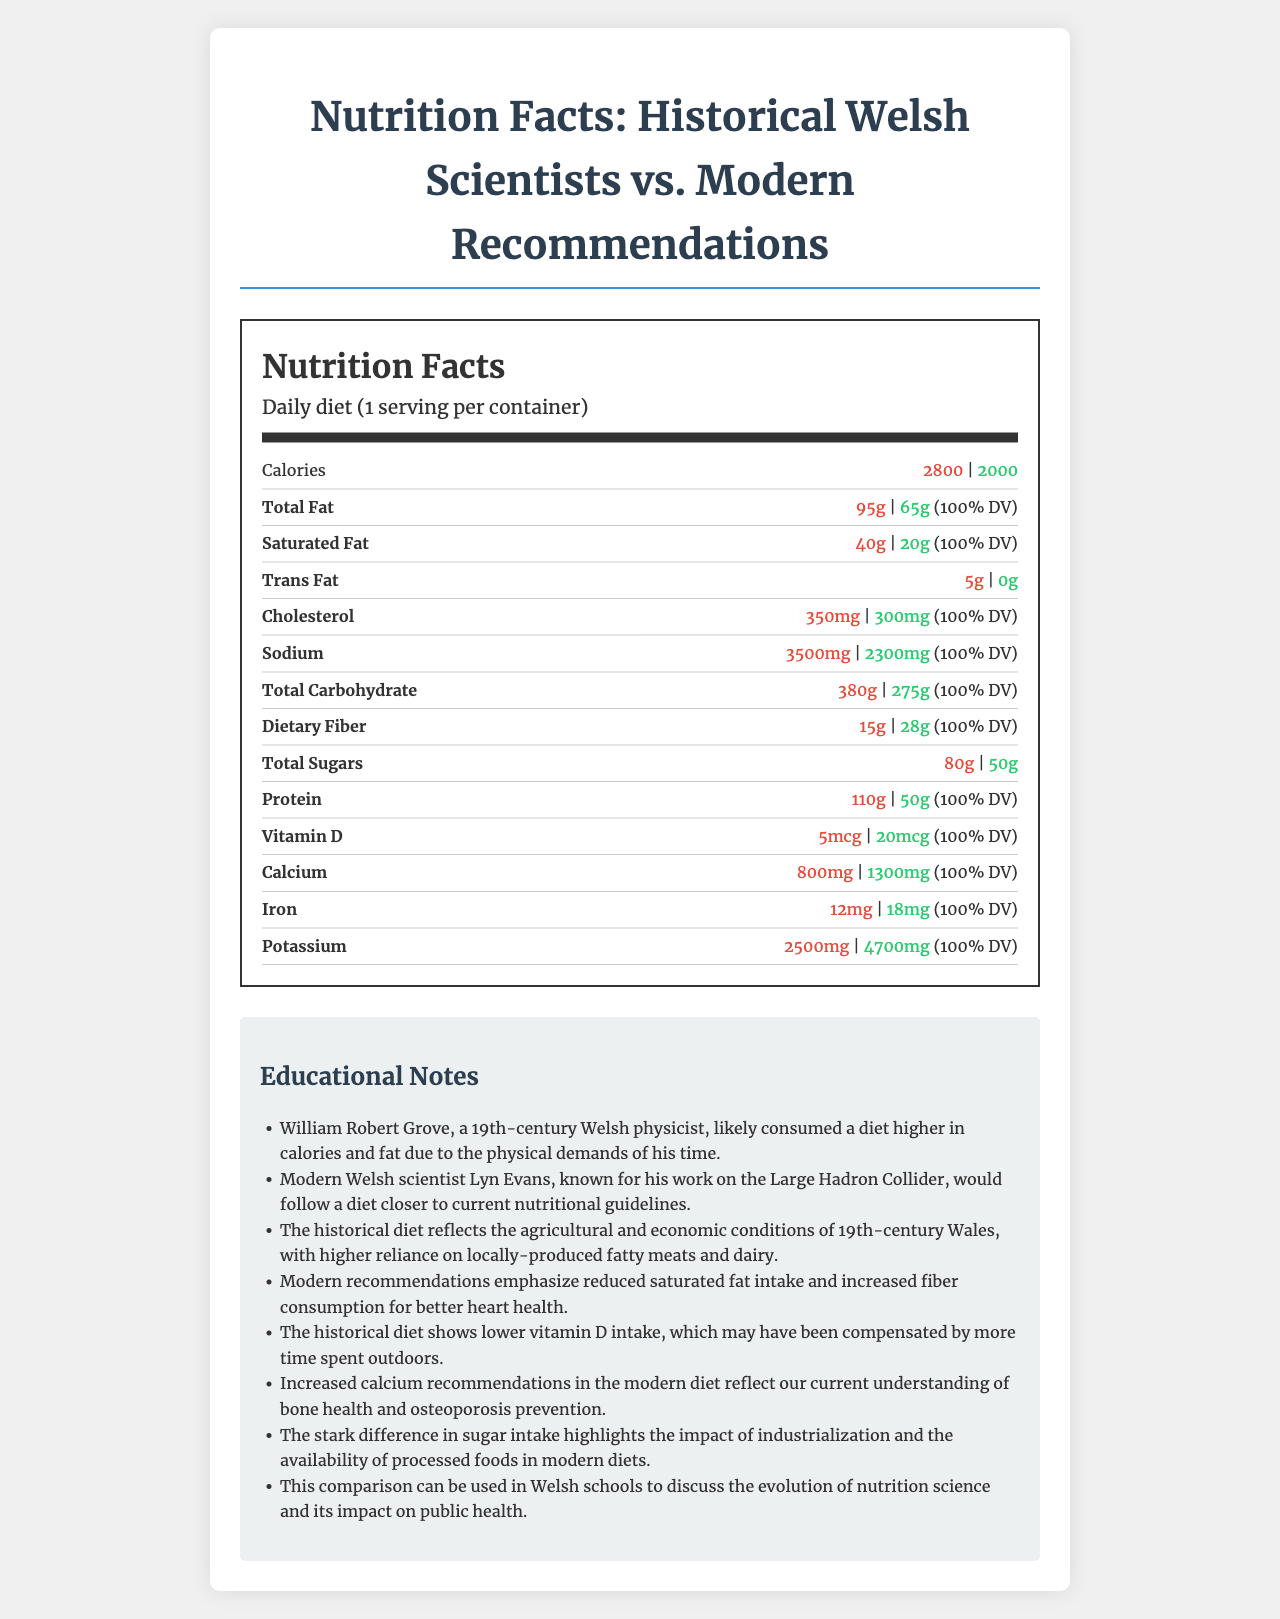what is the serving size for the daily diet of both historical and modern Welsh scientists? The document states that the serving size is "Daily diet" for both historical and modern Welsh scientists.
Answer: Daily diet how many calories did historical Welsh scientists consume per day compared to modern recommendations? The document shows that historical Welsh scientists consumed 2800 calories per day, while modern recommendations suggest 2000 calories per day.
Answer: Historical: 2800, Modern: 2000 what is the difference in total fat intake between historical and modern Welsh scientists? Historical Welsh scientists consumed 95g of total fat, whereas modern recommendations are 65g, making a difference of 30g.
Answer: 30g which nutrients have the same daily value percentage listed for both historical and modern diets? These nutrients have the same daily value percentage listed as 100%.
Answer: Total Fat, Saturated Fat, Cholesterol, Sodium, Total Carbohydrate, Dietary Fiber, Protein, Vitamin D, Calcium, Iron, Potassium how much Vitamin D did historical Welsh scientists consume compared to modern recommendations? The document shows that historical Welsh scientists consumed 5 mcg of Vitamin D, while modern recommendations suggest 20 mcg.
Answer: Historical: 5 mcg, Modern: 20 mcg compare the dietary fiber intake of historical and modern Welsh scientists. Historical Welsh scientists consumed 15g of dietary fiber, whereas modern recommendations suggest an intake of 28g.
Answer: Historical: 15g, Modern: 28g which nutrient's intake is higher in the modern diet compared to the historical diet? A. Total Sugars B. Saturated Fat C. Calcium D. Trans Fat The modern diet has a higher intake of Calcium at 1300 mg compared to 800 mg in the historical diet.
Answer: C. Calcium which is a healthier diet based on the nutrient intake, modern or historical? A. Modern B. Historical C. Neither The modern diet follows current nutritional guidelines with lower saturated fats and sugars, higher dietary fiber, and Vitamin D.
Answer: A. Modern did historical Welsh scientists have a higher or lower potassium intake compared to modern recommendations? Historical Welsh scientists had a potassium intake of 2500 mg compared to modern recommendations of 4700 mg.
Answer: Lower does the document mention the specific agricultural and economic conditions that influenced the historical diet? The educational notes mention the reliance on locally-produced fatty meats and dairy in 19th-century Wales, reflecting agricultural and economic conditions.
Answer: Yes summarize the main differences between the diets of historical Welsh scientists and modern recommendations. The document compares the higher calorie and fat-rich diet of historical Welsh scientists to the more balanced and health-conscious modern diet, highlighting specific nutrient differences and their implications on health.
Answer: Modern recommendations focus on lower intake of calories, fats (especially saturated and trans fats), sugars, and sodium, while increasing intake of dietary fiber, Vitamin D, calcium, and potassium. This reflects a shift towards improving heart health and understanding bone health. based on the document, what type of scientist is Lyn Evans? The document mentions that Lyn Evans is a modern Welsh scientist associated with current nutritional guidelines but does not specify the type of scientist he is beyond his work on the Large Hadron Collider.
Answer: Not enough information 